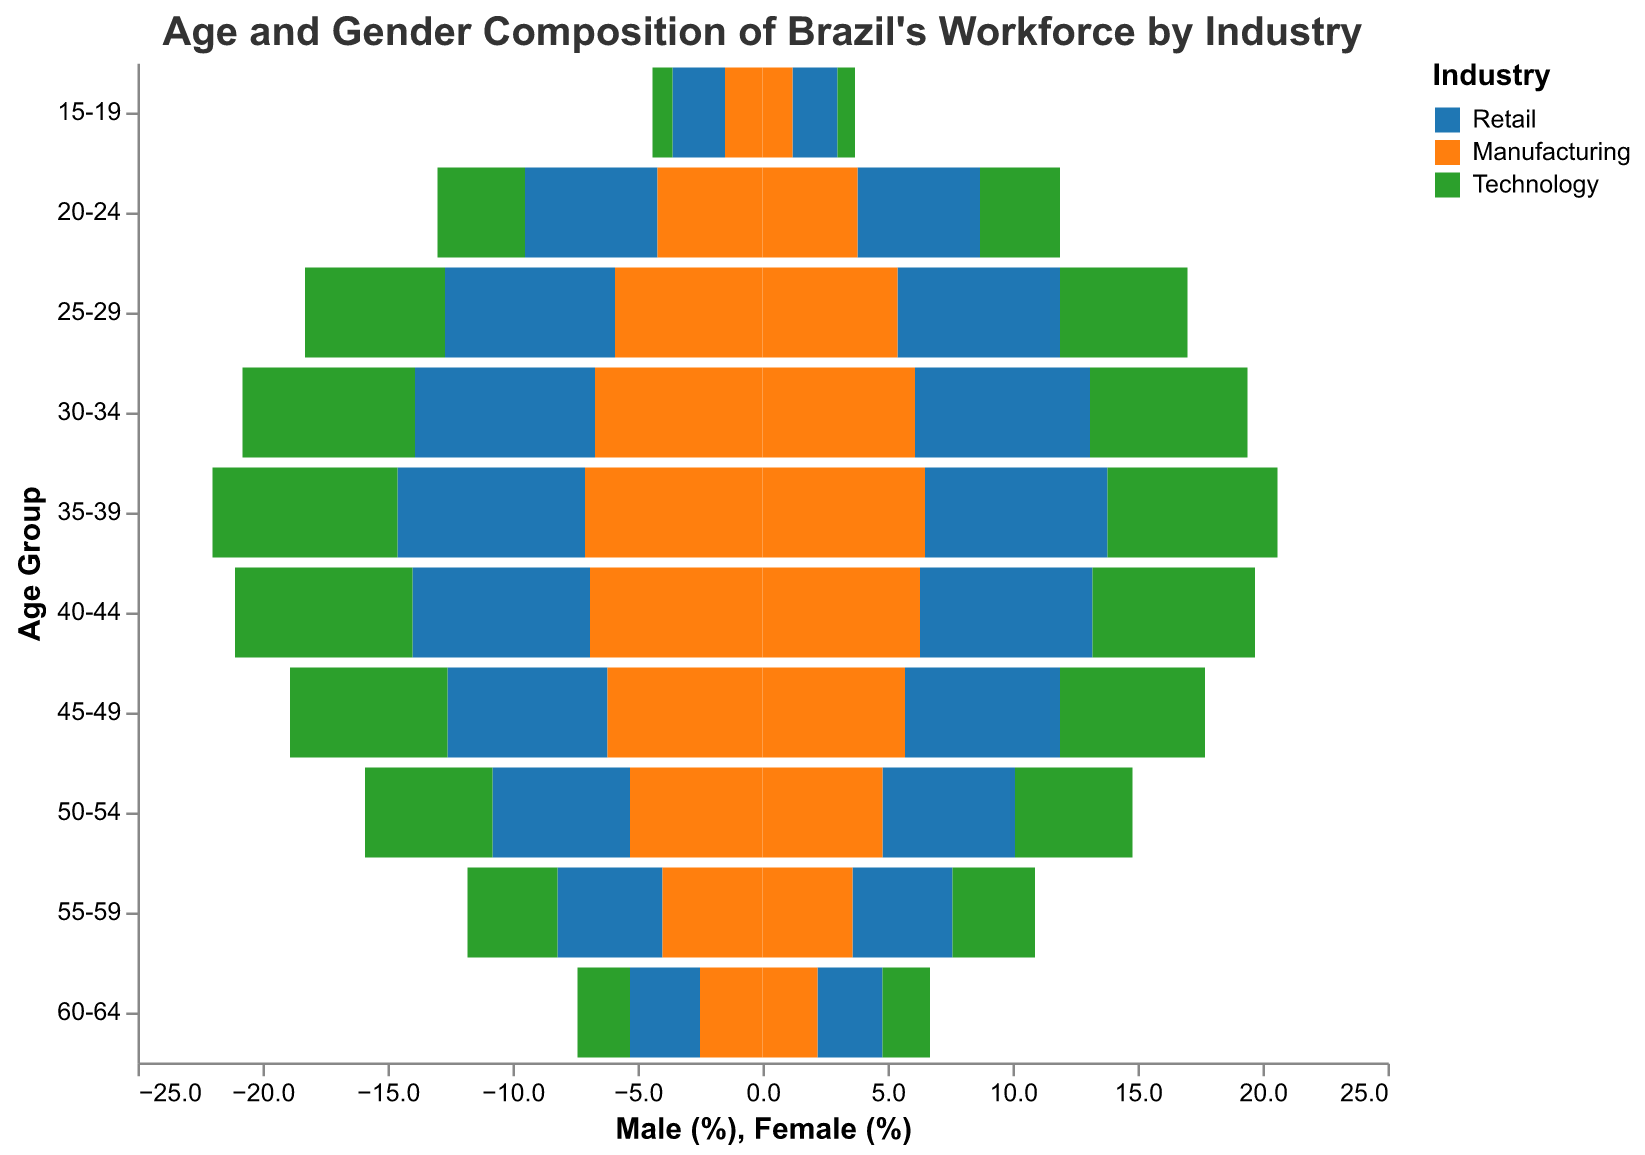What is the title of the figure? The title is displayed at the top of the figure and describes the overall content of the figure.
Answer: Age and Gender Composition of Brazil's Workforce by Industry Which age group has the highest percentage of males in the Retail industry? Look for the highest bar on the left side with the "Retail" color for males.
Answer: 35-39 How do the percentages of females in the 30-34 age group compare across the three industries? Observe the heights of the bars on the right side for the 30-34 age group in different colors.
Answer: Retail: 7.0%, Manufacturing: 6.1%, Technology: 6.3% In which industry and age group is there the smallest percentage of male workers? Find the shortest bar on the left side, regardless of color, and note the industry and age group it represents.
Answer: Technology, 15-19 age group What is the difference in the percentage of male workers between the 20-24 and 40-44 age groups in the Technology industry? Subtract the percentage of male workers in the 40-44 age group from that of the 20-24 age group for the same industry.
Answer: 3.5% - 7.1% = -3.6% Is the percentage of female workers aged 50-54 higher in Retail or Manufacturing? Compare the heights of the bars on the right side for the 50-54 age group in the colors representing Retail and Manufacturing.
Answer: Retail Which industry has a more uniformly distributed age composition among male workers? Compare the differences in bar heights on the left side across all age groups for each industry color to assess uniformity.
Answer: Retail In the 55-59 age group, which industry has the highest percentage of female workers, and what is the value? Look at the height of the bars on the right side for the 55-59 age group and identify the highest one.
Answer: Retail, 4.0% How does the gender composition of the 25-29 age group compare between Manufacturing and Technology industries? Compare the heights of the bars for both male and female workers in the 25-29 age group for both industries.
Answer: Males: Manufacturing 5.9%, Technology 5.6%; Females: Manufacturing 5.4%, Technology 5.1% Which industry has the smallest gender gap in the 35-39 age group? Calculate the absolute difference between male and female percentages in the 35-39 age group for each industry and find the smallest difference.
Answer: Retail 